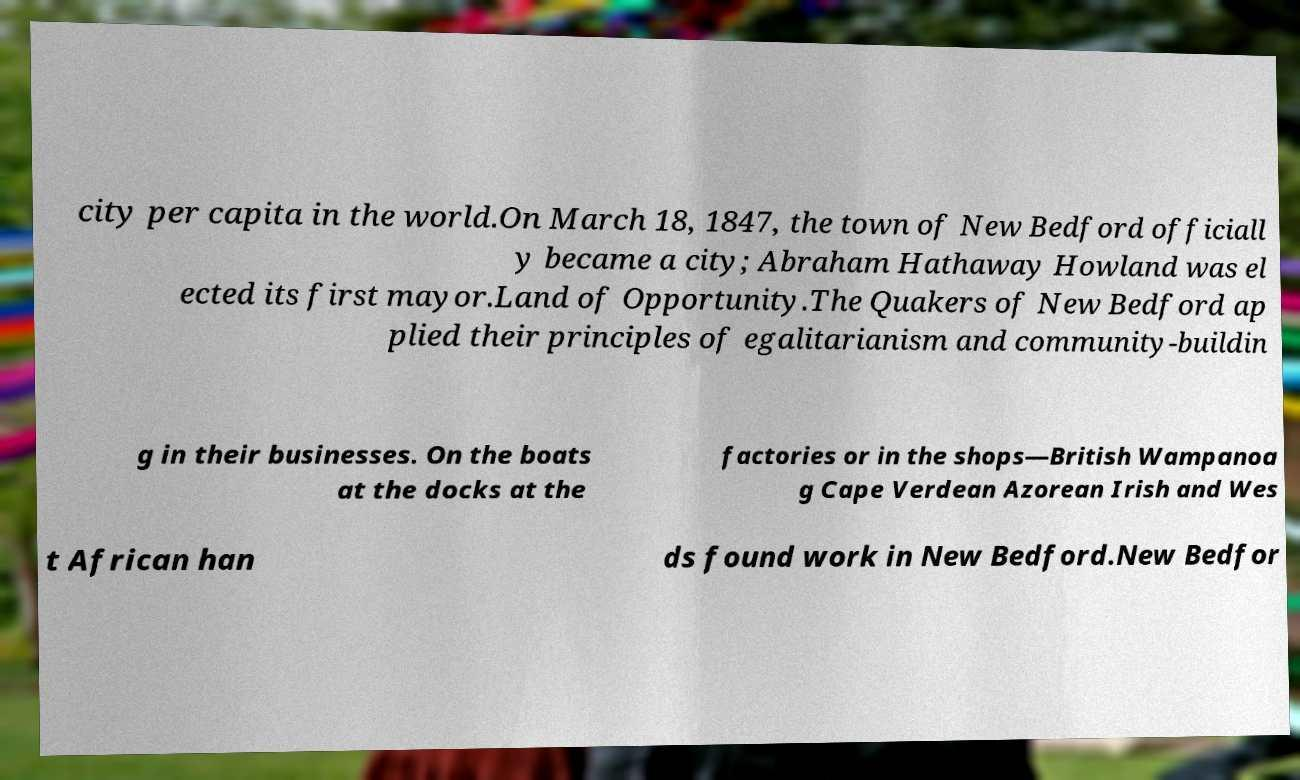I need the written content from this picture converted into text. Can you do that? city per capita in the world.On March 18, 1847, the town of New Bedford officiall y became a city; Abraham Hathaway Howland was el ected its first mayor.Land of Opportunity.The Quakers of New Bedford ap plied their principles of egalitarianism and community-buildin g in their businesses. On the boats at the docks at the factories or in the shops—British Wampanoa g Cape Verdean Azorean Irish and Wes t African han ds found work in New Bedford.New Bedfor 